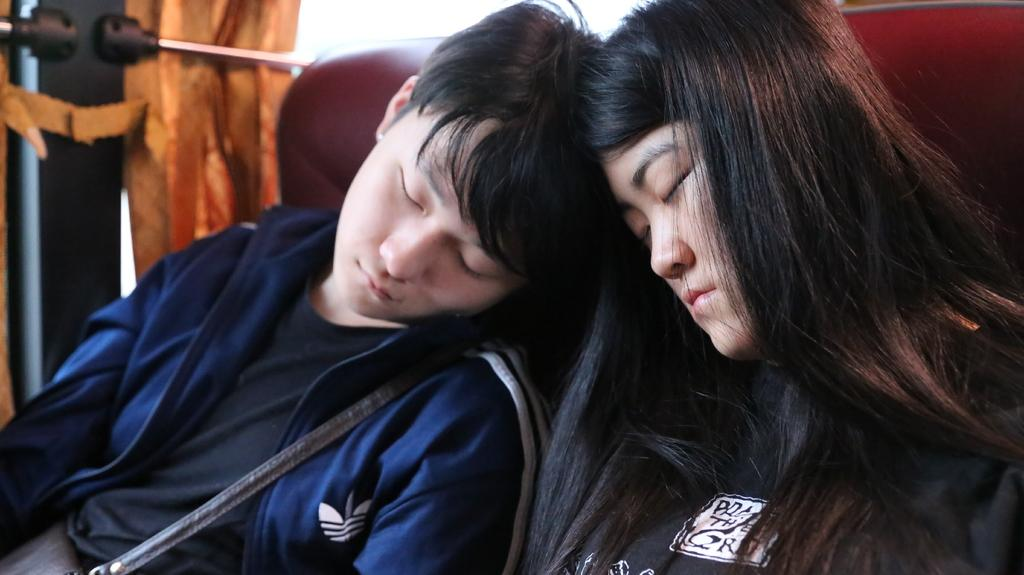Who is present in the image? There is a man and a woman in the image. What are the man and woman doing in the image? The man and woman are sleeping in the image. Where are the man and woman sitting? They are sitting on a sofa in the image. What can be seen in the background of the image? There are curtains in the image. What object is present near the woman? There is a handbag in the image. What type of riddle can be solved using the zinc in the image? There is no zinc present in the image, and therefore no riddle can be solved using it. 